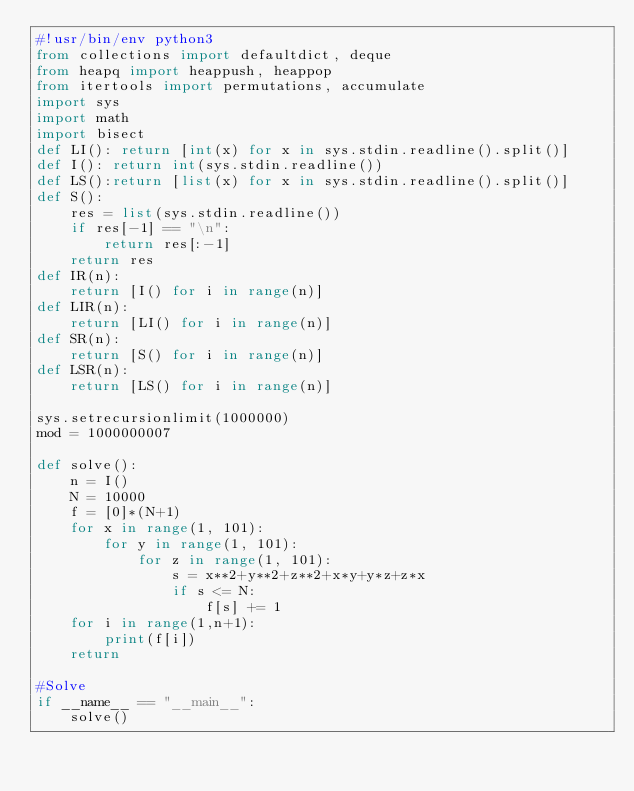Convert code to text. <code><loc_0><loc_0><loc_500><loc_500><_Python_>#!usr/bin/env python3
from collections import defaultdict, deque
from heapq import heappush, heappop
from itertools import permutations, accumulate
import sys
import math
import bisect
def LI(): return [int(x) for x in sys.stdin.readline().split()]
def I(): return int(sys.stdin.readline())
def LS():return [list(x) for x in sys.stdin.readline().split()]
def S():
    res = list(sys.stdin.readline())
    if res[-1] == "\n":
        return res[:-1]
    return res
def IR(n):
    return [I() for i in range(n)]
def LIR(n):
    return [LI() for i in range(n)]
def SR(n):
    return [S() for i in range(n)]
def LSR(n):
    return [LS() for i in range(n)]

sys.setrecursionlimit(1000000)
mod = 1000000007

def solve():
    n = I()
    N = 10000
    f = [0]*(N+1)
    for x in range(1, 101):
        for y in range(1, 101):
            for z in range(1, 101):
                s = x**2+y**2+z**2+x*y+y*z+z*x
                if s <= N:
                    f[s] += 1
    for i in range(1,n+1):
        print(f[i])
    return

#Solve
if __name__ == "__main__":
    solve()
</code> 